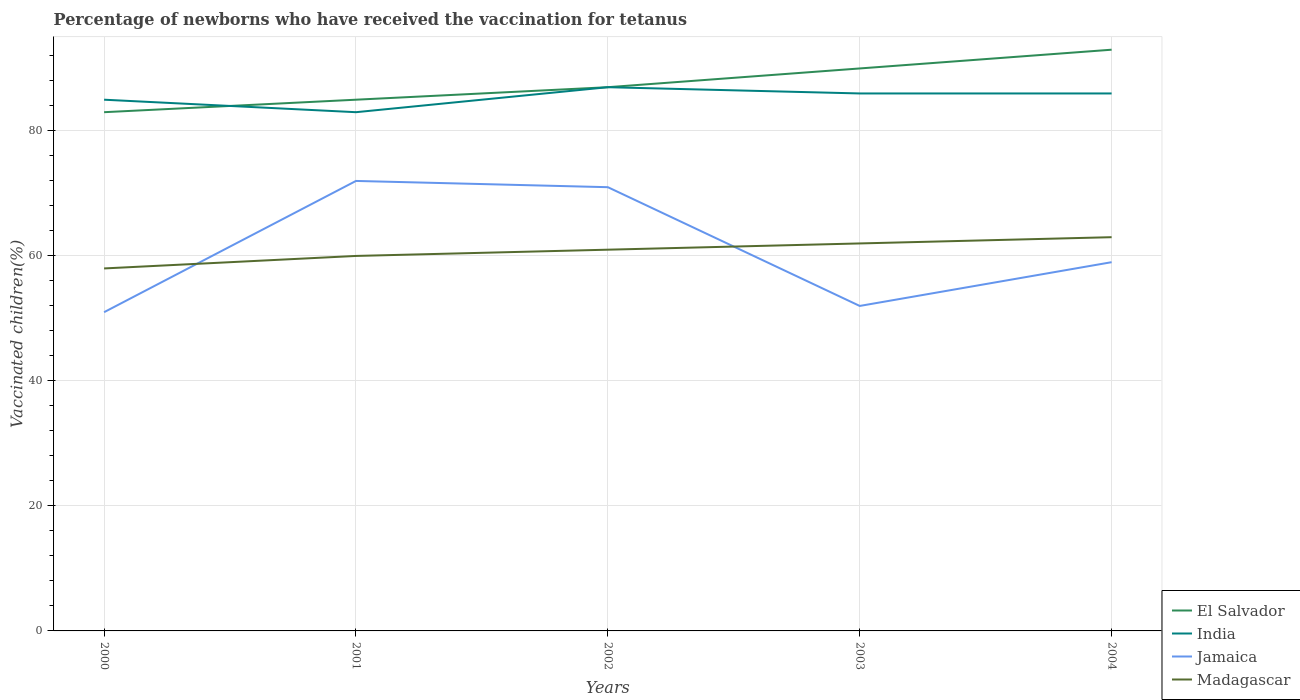How many different coloured lines are there?
Your response must be concise. 4. Does the line corresponding to Madagascar intersect with the line corresponding to India?
Provide a short and direct response. No. Across all years, what is the maximum percentage of vaccinated children in Jamaica?
Keep it short and to the point. 51. What is the difference between the highest and the second highest percentage of vaccinated children in India?
Provide a short and direct response. 4. Is the percentage of vaccinated children in Jamaica strictly greater than the percentage of vaccinated children in El Salvador over the years?
Your answer should be very brief. Yes. What is the difference between two consecutive major ticks on the Y-axis?
Give a very brief answer. 20. Where does the legend appear in the graph?
Give a very brief answer. Bottom right. What is the title of the graph?
Make the answer very short. Percentage of newborns who have received the vaccination for tetanus. Does "Malta" appear as one of the legend labels in the graph?
Make the answer very short. No. What is the label or title of the X-axis?
Provide a short and direct response. Years. What is the label or title of the Y-axis?
Offer a terse response. Vaccinated children(%). What is the Vaccinated children(%) of India in 2000?
Ensure brevity in your answer.  85. What is the Vaccinated children(%) in Madagascar in 2000?
Provide a succinct answer. 58. What is the Vaccinated children(%) in India in 2001?
Provide a short and direct response. 83. What is the Vaccinated children(%) of Jamaica in 2001?
Keep it short and to the point. 72. What is the Vaccinated children(%) of India in 2002?
Your response must be concise. 87. What is the Vaccinated children(%) of Jamaica in 2002?
Offer a terse response. 71. What is the Vaccinated children(%) of India in 2003?
Your answer should be very brief. 86. What is the Vaccinated children(%) of El Salvador in 2004?
Offer a terse response. 93. Across all years, what is the maximum Vaccinated children(%) in El Salvador?
Your answer should be very brief. 93. Across all years, what is the maximum Vaccinated children(%) of India?
Keep it short and to the point. 87. Across all years, what is the maximum Vaccinated children(%) of Jamaica?
Ensure brevity in your answer.  72. Across all years, what is the minimum Vaccinated children(%) in El Salvador?
Your response must be concise. 83. Across all years, what is the minimum Vaccinated children(%) in Jamaica?
Your answer should be very brief. 51. Across all years, what is the minimum Vaccinated children(%) of Madagascar?
Provide a short and direct response. 58. What is the total Vaccinated children(%) in El Salvador in the graph?
Make the answer very short. 438. What is the total Vaccinated children(%) in India in the graph?
Offer a very short reply. 427. What is the total Vaccinated children(%) of Jamaica in the graph?
Ensure brevity in your answer.  305. What is the total Vaccinated children(%) in Madagascar in the graph?
Make the answer very short. 304. What is the difference between the Vaccinated children(%) of India in 2000 and that in 2001?
Your answer should be very brief. 2. What is the difference between the Vaccinated children(%) in Jamaica in 2000 and that in 2001?
Make the answer very short. -21. What is the difference between the Vaccinated children(%) in Madagascar in 2000 and that in 2001?
Make the answer very short. -2. What is the difference between the Vaccinated children(%) in El Salvador in 2000 and that in 2002?
Offer a terse response. -4. What is the difference between the Vaccinated children(%) in India in 2000 and that in 2002?
Make the answer very short. -2. What is the difference between the Vaccinated children(%) in Jamaica in 2000 and that in 2002?
Your answer should be very brief. -20. What is the difference between the Vaccinated children(%) of Madagascar in 2000 and that in 2002?
Make the answer very short. -3. What is the difference between the Vaccinated children(%) in El Salvador in 2000 and that in 2003?
Give a very brief answer. -7. What is the difference between the Vaccinated children(%) of India in 2000 and that in 2003?
Your answer should be compact. -1. What is the difference between the Vaccinated children(%) in El Salvador in 2000 and that in 2004?
Your response must be concise. -10. What is the difference between the Vaccinated children(%) of Jamaica in 2000 and that in 2004?
Provide a short and direct response. -8. What is the difference between the Vaccinated children(%) in Madagascar in 2000 and that in 2004?
Offer a very short reply. -5. What is the difference between the Vaccinated children(%) in El Salvador in 2001 and that in 2002?
Your response must be concise. -2. What is the difference between the Vaccinated children(%) of India in 2001 and that in 2002?
Your answer should be very brief. -4. What is the difference between the Vaccinated children(%) of Jamaica in 2001 and that in 2002?
Give a very brief answer. 1. What is the difference between the Vaccinated children(%) in India in 2001 and that in 2003?
Your answer should be very brief. -3. What is the difference between the Vaccinated children(%) in Jamaica in 2001 and that in 2003?
Offer a terse response. 20. What is the difference between the Vaccinated children(%) of Madagascar in 2001 and that in 2003?
Offer a very short reply. -2. What is the difference between the Vaccinated children(%) of Madagascar in 2001 and that in 2004?
Offer a terse response. -3. What is the difference between the Vaccinated children(%) in India in 2002 and that in 2003?
Offer a terse response. 1. What is the difference between the Vaccinated children(%) of Jamaica in 2002 and that in 2003?
Keep it short and to the point. 19. What is the difference between the Vaccinated children(%) of El Salvador in 2002 and that in 2004?
Make the answer very short. -6. What is the difference between the Vaccinated children(%) in Jamaica in 2002 and that in 2004?
Ensure brevity in your answer.  12. What is the difference between the Vaccinated children(%) of India in 2003 and that in 2004?
Offer a very short reply. 0. What is the difference between the Vaccinated children(%) of Jamaica in 2003 and that in 2004?
Offer a very short reply. -7. What is the difference between the Vaccinated children(%) in Madagascar in 2003 and that in 2004?
Your answer should be compact. -1. What is the difference between the Vaccinated children(%) in El Salvador in 2000 and the Vaccinated children(%) in India in 2001?
Keep it short and to the point. 0. What is the difference between the Vaccinated children(%) in El Salvador in 2000 and the Vaccinated children(%) in Madagascar in 2001?
Offer a very short reply. 23. What is the difference between the Vaccinated children(%) of India in 2000 and the Vaccinated children(%) of Jamaica in 2001?
Your answer should be compact. 13. What is the difference between the Vaccinated children(%) in India in 2000 and the Vaccinated children(%) in Madagascar in 2001?
Ensure brevity in your answer.  25. What is the difference between the Vaccinated children(%) in Jamaica in 2000 and the Vaccinated children(%) in Madagascar in 2001?
Your answer should be compact. -9. What is the difference between the Vaccinated children(%) of El Salvador in 2000 and the Vaccinated children(%) of India in 2002?
Provide a short and direct response. -4. What is the difference between the Vaccinated children(%) in Jamaica in 2000 and the Vaccinated children(%) in Madagascar in 2002?
Provide a succinct answer. -10. What is the difference between the Vaccinated children(%) of El Salvador in 2000 and the Vaccinated children(%) of Jamaica in 2003?
Your answer should be compact. 31. What is the difference between the Vaccinated children(%) of India in 2000 and the Vaccinated children(%) of Jamaica in 2003?
Offer a very short reply. 33. What is the difference between the Vaccinated children(%) in Jamaica in 2000 and the Vaccinated children(%) in Madagascar in 2003?
Offer a very short reply. -11. What is the difference between the Vaccinated children(%) of El Salvador in 2000 and the Vaccinated children(%) of India in 2004?
Provide a short and direct response. -3. What is the difference between the Vaccinated children(%) of El Salvador in 2000 and the Vaccinated children(%) of Jamaica in 2004?
Provide a short and direct response. 24. What is the difference between the Vaccinated children(%) in Jamaica in 2000 and the Vaccinated children(%) in Madagascar in 2004?
Your answer should be very brief. -12. What is the difference between the Vaccinated children(%) of El Salvador in 2001 and the Vaccinated children(%) of India in 2002?
Offer a terse response. -2. What is the difference between the Vaccinated children(%) in El Salvador in 2001 and the Vaccinated children(%) in Jamaica in 2002?
Offer a terse response. 14. What is the difference between the Vaccinated children(%) in El Salvador in 2001 and the Vaccinated children(%) in Madagascar in 2002?
Make the answer very short. 24. What is the difference between the Vaccinated children(%) in India in 2001 and the Vaccinated children(%) in Madagascar in 2002?
Make the answer very short. 22. What is the difference between the Vaccinated children(%) of Jamaica in 2001 and the Vaccinated children(%) of Madagascar in 2002?
Your answer should be compact. 11. What is the difference between the Vaccinated children(%) in El Salvador in 2001 and the Vaccinated children(%) in India in 2003?
Offer a very short reply. -1. What is the difference between the Vaccinated children(%) of El Salvador in 2001 and the Vaccinated children(%) of Jamaica in 2003?
Ensure brevity in your answer.  33. What is the difference between the Vaccinated children(%) of El Salvador in 2001 and the Vaccinated children(%) of Madagascar in 2003?
Ensure brevity in your answer.  23. What is the difference between the Vaccinated children(%) in India in 2001 and the Vaccinated children(%) in Jamaica in 2003?
Ensure brevity in your answer.  31. What is the difference between the Vaccinated children(%) of Jamaica in 2001 and the Vaccinated children(%) of Madagascar in 2003?
Your answer should be compact. 10. What is the difference between the Vaccinated children(%) of India in 2001 and the Vaccinated children(%) of Jamaica in 2004?
Offer a very short reply. 24. What is the difference between the Vaccinated children(%) in India in 2001 and the Vaccinated children(%) in Madagascar in 2004?
Offer a terse response. 20. What is the difference between the Vaccinated children(%) of El Salvador in 2002 and the Vaccinated children(%) of Madagascar in 2003?
Your answer should be compact. 25. What is the difference between the Vaccinated children(%) of El Salvador in 2002 and the Vaccinated children(%) of India in 2004?
Make the answer very short. 1. What is the difference between the Vaccinated children(%) of El Salvador in 2002 and the Vaccinated children(%) of Madagascar in 2004?
Offer a very short reply. 24. What is the difference between the Vaccinated children(%) of India in 2002 and the Vaccinated children(%) of Madagascar in 2004?
Provide a short and direct response. 24. What is the difference between the Vaccinated children(%) of India in 2003 and the Vaccinated children(%) of Madagascar in 2004?
Keep it short and to the point. 23. What is the average Vaccinated children(%) in El Salvador per year?
Offer a very short reply. 87.6. What is the average Vaccinated children(%) in India per year?
Make the answer very short. 85.4. What is the average Vaccinated children(%) in Jamaica per year?
Provide a short and direct response. 61. What is the average Vaccinated children(%) of Madagascar per year?
Your answer should be compact. 60.8. In the year 2000, what is the difference between the Vaccinated children(%) of El Salvador and Vaccinated children(%) of Jamaica?
Ensure brevity in your answer.  32. In the year 2000, what is the difference between the Vaccinated children(%) of Jamaica and Vaccinated children(%) of Madagascar?
Offer a very short reply. -7. In the year 2001, what is the difference between the Vaccinated children(%) in El Salvador and Vaccinated children(%) in India?
Provide a succinct answer. 2. In the year 2001, what is the difference between the Vaccinated children(%) in El Salvador and Vaccinated children(%) in Madagascar?
Ensure brevity in your answer.  25. In the year 2001, what is the difference between the Vaccinated children(%) in India and Vaccinated children(%) in Madagascar?
Offer a terse response. 23. In the year 2001, what is the difference between the Vaccinated children(%) of Jamaica and Vaccinated children(%) of Madagascar?
Provide a succinct answer. 12. In the year 2002, what is the difference between the Vaccinated children(%) in El Salvador and Vaccinated children(%) in Jamaica?
Ensure brevity in your answer.  16. In the year 2002, what is the difference between the Vaccinated children(%) in El Salvador and Vaccinated children(%) in Madagascar?
Provide a succinct answer. 26. In the year 2002, what is the difference between the Vaccinated children(%) in India and Vaccinated children(%) in Jamaica?
Keep it short and to the point. 16. In the year 2002, what is the difference between the Vaccinated children(%) of India and Vaccinated children(%) of Madagascar?
Provide a succinct answer. 26. In the year 2002, what is the difference between the Vaccinated children(%) of Jamaica and Vaccinated children(%) of Madagascar?
Offer a very short reply. 10. In the year 2003, what is the difference between the Vaccinated children(%) of El Salvador and Vaccinated children(%) of India?
Offer a very short reply. 4. In the year 2003, what is the difference between the Vaccinated children(%) in El Salvador and Vaccinated children(%) in Jamaica?
Your response must be concise. 38. In the year 2003, what is the difference between the Vaccinated children(%) in El Salvador and Vaccinated children(%) in Madagascar?
Keep it short and to the point. 28. In the year 2003, what is the difference between the Vaccinated children(%) in India and Vaccinated children(%) in Jamaica?
Provide a succinct answer. 34. In the year 2003, what is the difference between the Vaccinated children(%) in Jamaica and Vaccinated children(%) in Madagascar?
Your answer should be compact. -10. In the year 2004, what is the difference between the Vaccinated children(%) in El Salvador and Vaccinated children(%) in Madagascar?
Give a very brief answer. 30. In the year 2004, what is the difference between the Vaccinated children(%) in India and Vaccinated children(%) in Madagascar?
Offer a very short reply. 23. What is the ratio of the Vaccinated children(%) of El Salvador in 2000 to that in 2001?
Your answer should be compact. 0.98. What is the ratio of the Vaccinated children(%) of India in 2000 to that in 2001?
Your answer should be very brief. 1.02. What is the ratio of the Vaccinated children(%) in Jamaica in 2000 to that in 2001?
Your response must be concise. 0.71. What is the ratio of the Vaccinated children(%) of Madagascar in 2000 to that in 2001?
Your answer should be very brief. 0.97. What is the ratio of the Vaccinated children(%) in El Salvador in 2000 to that in 2002?
Ensure brevity in your answer.  0.95. What is the ratio of the Vaccinated children(%) in Jamaica in 2000 to that in 2002?
Offer a very short reply. 0.72. What is the ratio of the Vaccinated children(%) in Madagascar in 2000 to that in 2002?
Provide a short and direct response. 0.95. What is the ratio of the Vaccinated children(%) in El Salvador in 2000 to that in 2003?
Your answer should be compact. 0.92. What is the ratio of the Vaccinated children(%) in India in 2000 to that in 2003?
Offer a very short reply. 0.99. What is the ratio of the Vaccinated children(%) of Jamaica in 2000 to that in 2003?
Make the answer very short. 0.98. What is the ratio of the Vaccinated children(%) in Madagascar in 2000 to that in 2003?
Provide a succinct answer. 0.94. What is the ratio of the Vaccinated children(%) in El Salvador in 2000 to that in 2004?
Make the answer very short. 0.89. What is the ratio of the Vaccinated children(%) of India in 2000 to that in 2004?
Keep it short and to the point. 0.99. What is the ratio of the Vaccinated children(%) of Jamaica in 2000 to that in 2004?
Provide a short and direct response. 0.86. What is the ratio of the Vaccinated children(%) of Madagascar in 2000 to that in 2004?
Your response must be concise. 0.92. What is the ratio of the Vaccinated children(%) of India in 2001 to that in 2002?
Make the answer very short. 0.95. What is the ratio of the Vaccinated children(%) in Jamaica in 2001 to that in 2002?
Provide a short and direct response. 1.01. What is the ratio of the Vaccinated children(%) of Madagascar in 2001 to that in 2002?
Give a very brief answer. 0.98. What is the ratio of the Vaccinated children(%) in El Salvador in 2001 to that in 2003?
Make the answer very short. 0.94. What is the ratio of the Vaccinated children(%) of India in 2001 to that in 2003?
Offer a terse response. 0.97. What is the ratio of the Vaccinated children(%) of Jamaica in 2001 to that in 2003?
Make the answer very short. 1.38. What is the ratio of the Vaccinated children(%) of El Salvador in 2001 to that in 2004?
Ensure brevity in your answer.  0.91. What is the ratio of the Vaccinated children(%) of India in 2001 to that in 2004?
Ensure brevity in your answer.  0.97. What is the ratio of the Vaccinated children(%) of Jamaica in 2001 to that in 2004?
Your answer should be compact. 1.22. What is the ratio of the Vaccinated children(%) in El Salvador in 2002 to that in 2003?
Offer a very short reply. 0.97. What is the ratio of the Vaccinated children(%) of India in 2002 to that in 2003?
Your answer should be very brief. 1.01. What is the ratio of the Vaccinated children(%) in Jamaica in 2002 to that in 2003?
Your answer should be compact. 1.37. What is the ratio of the Vaccinated children(%) of Madagascar in 2002 to that in 2003?
Your answer should be compact. 0.98. What is the ratio of the Vaccinated children(%) of El Salvador in 2002 to that in 2004?
Make the answer very short. 0.94. What is the ratio of the Vaccinated children(%) of India in 2002 to that in 2004?
Provide a succinct answer. 1.01. What is the ratio of the Vaccinated children(%) of Jamaica in 2002 to that in 2004?
Offer a terse response. 1.2. What is the ratio of the Vaccinated children(%) of Madagascar in 2002 to that in 2004?
Offer a terse response. 0.97. What is the ratio of the Vaccinated children(%) of India in 2003 to that in 2004?
Give a very brief answer. 1. What is the ratio of the Vaccinated children(%) in Jamaica in 2003 to that in 2004?
Keep it short and to the point. 0.88. What is the ratio of the Vaccinated children(%) in Madagascar in 2003 to that in 2004?
Your answer should be compact. 0.98. What is the difference between the highest and the second highest Vaccinated children(%) of Madagascar?
Your response must be concise. 1. What is the difference between the highest and the lowest Vaccinated children(%) of India?
Ensure brevity in your answer.  4. What is the difference between the highest and the lowest Vaccinated children(%) in Madagascar?
Your answer should be compact. 5. 